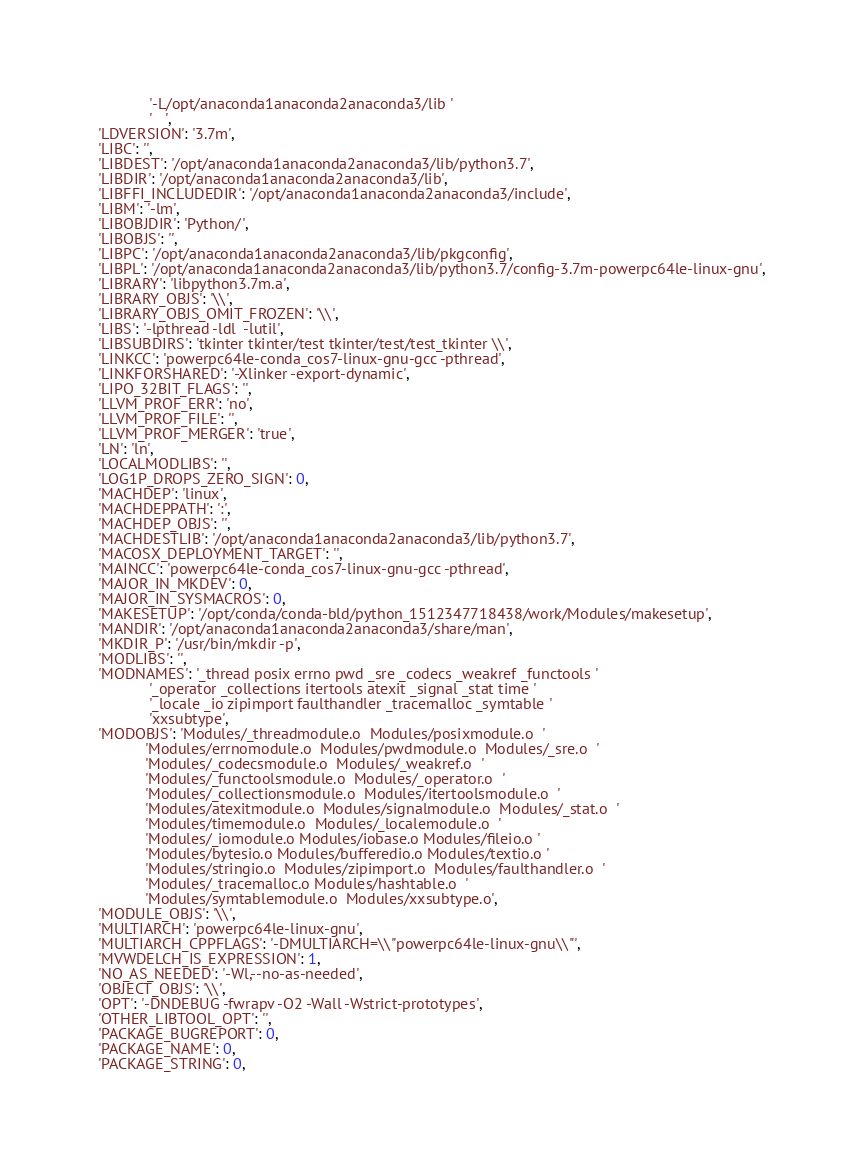<code> <loc_0><loc_0><loc_500><loc_500><_Python_>             '-L/opt/anaconda1anaconda2anaconda3/lib '
             '   ',
 'LDVERSION': '3.7m',
 'LIBC': '',
 'LIBDEST': '/opt/anaconda1anaconda2anaconda3/lib/python3.7',
 'LIBDIR': '/opt/anaconda1anaconda2anaconda3/lib',
 'LIBFFI_INCLUDEDIR': '/opt/anaconda1anaconda2anaconda3/include',
 'LIBM': '-lm',
 'LIBOBJDIR': 'Python/',
 'LIBOBJS': '',
 'LIBPC': '/opt/anaconda1anaconda2anaconda3/lib/pkgconfig',
 'LIBPL': '/opt/anaconda1anaconda2anaconda3/lib/python3.7/config-3.7m-powerpc64le-linux-gnu',
 'LIBRARY': 'libpython3.7m.a',
 'LIBRARY_OBJS': '\\',
 'LIBRARY_OBJS_OMIT_FROZEN': '\\',
 'LIBS': '-lpthread -ldl  -lutil',
 'LIBSUBDIRS': 'tkinter tkinter/test tkinter/test/test_tkinter \\',
 'LINKCC': 'powerpc64le-conda_cos7-linux-gnu-gcc -pthread',
 'LINKFORSHARED': '-Xlinker -export-dynamic',
 'LIPO_32BIT_FLAGS': '',
 'LLVM_PROF_ERR': 'no',
 'LLVM_PROF_FILE': '',
 'LLVM_PROF_MERGER': 'true',
 'LN': 'ln',
 'LOCALMODLIBS': '',
 'LOG1P_DROPS_ZERO_SIGN': 0,
 'MACHDEP': 'linux',
 'MACHDEPPATH': ':',
 'MACHDEP_OBJS': '',
 'MACHDESTLIB': '/opt/anaconda1anaconda2anaconda3/lib/python3.7',
 'MACOSX_DEPLOYMENT_TARGET': '',
 'MAINCC': 'powerpc64le-conda_cos7-linux-gnu-gcc -pthread',
 'MAJOR_IN_MKDEV': 0,
 'MAJOR_IN_SYSMACROS': 0,
 'MAKESETUP': '/opt/conda/conda-bld/python_1512347718438/work/Modules/makesetup',
 'MANDIR': '/opt/anaconda1anaconda2anaconda3/share/man',
 'MKDIR_P': '/usr/bin/mkdir -p',
 'MODLIBS': '',
 'MODNAMES': '_thread posix errno pwd _sre _codecs _weakref _functools '
             '_operator _collections itertools atexit _signal _stat time '
             '_locale _io zipimport faulthandler _tracemalloc _symtable '
             'xxsubtype',
 'MODOBJS': 'Modules/_threadmodule.o  Modules/posixmodule.o  '
            'Modules/errnomodule.o  Modules/pwdmodule.o  Modules/_sre.o  '
            'Modules/_codecsmodule.o  Modules/_weakref.o  '
            'Modules/_functoolsmodule.o  Modules/_operator.o  '
            'Modules/_collectionsmodule.o  Modules/itertoolsmodule.o  '
            'Modules/atexitmodule.o  Modules/signalmodule.o  Modules/_stat.o  '
            'Modules/timemodule.o  Modules/_localemodule.o  '
            'Modules/_iomodule.o Modules/iobase.o Modules/fileio.o '
            'Modules/bytesio.o Modules/bufferedio.o Modules/textio.o '
            'Modules/stringio.o  Modules/zipimport.o  Modules/faulthandler.o  '
            'Modules/_tracemalloc.o Modules/hashtable.o  '
            'Modules/symtablemodule.o  Modules/xxsubtype.o',
 'MODULE_OBJS': '\\',
 'MULTIARCH': 'powerpc64le-linux-gnu',
 'MULTIARCH_CPPFLAGS': '-DMULTIARCH=\\"powerpc64le-linux-gnu\\"',
 'MVWDELCH_IS_EXPRESSION': 1,
 'NO_AS_NEEDED': '-Wl,--no-as-needed',
 'OBJECT_OBJS': '\\',
 'OPT': '-DNDEBUG -fwrapv -O2 -Wall -Wstrict-prototypes',
 'OTHER_LIBTOOL_OPT': '',
 'PACKAGE_BUGREPORT': 0,
 'PACKAGE_NAME': 0,
 'PACKAGE_STRING': 0,</code> 